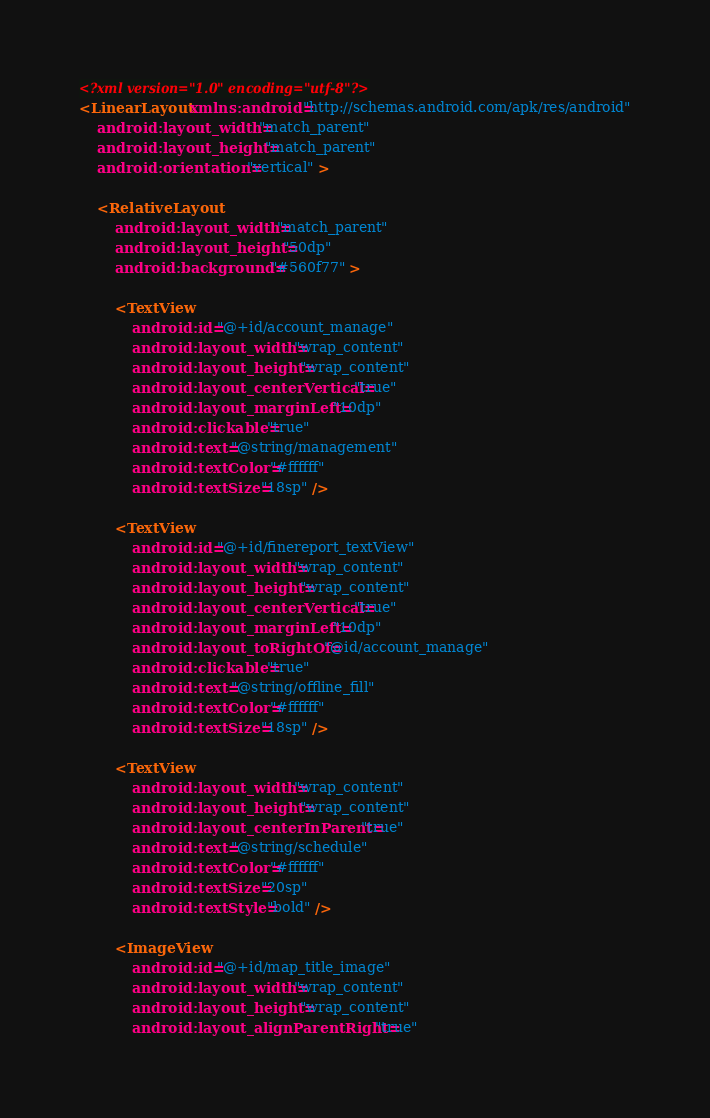Convert code to text. <code><loc_0><loc_0><loc_500><loc_500><_XML_><?xml version="1.0" encoding="utf-8"?>
<LinearLayout xmlns:android="http://schemas.android.com/apk/res/android"
    android:layout_width="match_parent"
    android:layout_height="match_parent"
    android:orientation="vertical" >

    <RelativeLayout
        android:layout_width="match_parent"
        android:layout_height="50dp"
        android:background="#560f77" >

        <TextView
            android:id="@+id/account_manage"
            android:layout_width="wrap_content"
            android:layout_height="wrap_content"
            android:layout_centerVertical="true"
            android:layout_marginLeft="10dp"
            android:clickable="true"
            android:text="@string/management"
            android:textColor="#ffffff"
            android:textSize="18sp" />

        <TextView
            android:id="@+id/finereport_textView"
            android:layout_width="wrap_content"
            android:layout_height="wrap_content"
            android:layout_centerVertical="true"
            android:layout_marginLeft="10dp"
            android:layout_toRightOf="@id/account_manage"
            android:clickable="true"
            android:text="@string/offline_fill"
            android:textColor="#ffffff"
            android:textSize="18sp" />
        
        <TextView
            android:layout_width="wrap_content"
            android:layout_height="wrap_content"
            android:layout_centerInParent="true"
            android:text="@string/schedule"
            android:textColor="#ffffff"
            android:textSize="20sp"
            android:textStyle="bold" />
        
        <ImageView
            android:id="@+id/map_title_image"
            android:layout_width="wrap_content"
            android:layout_height="wrap_content"
            android:layout_alignParentRight="true"</code> 